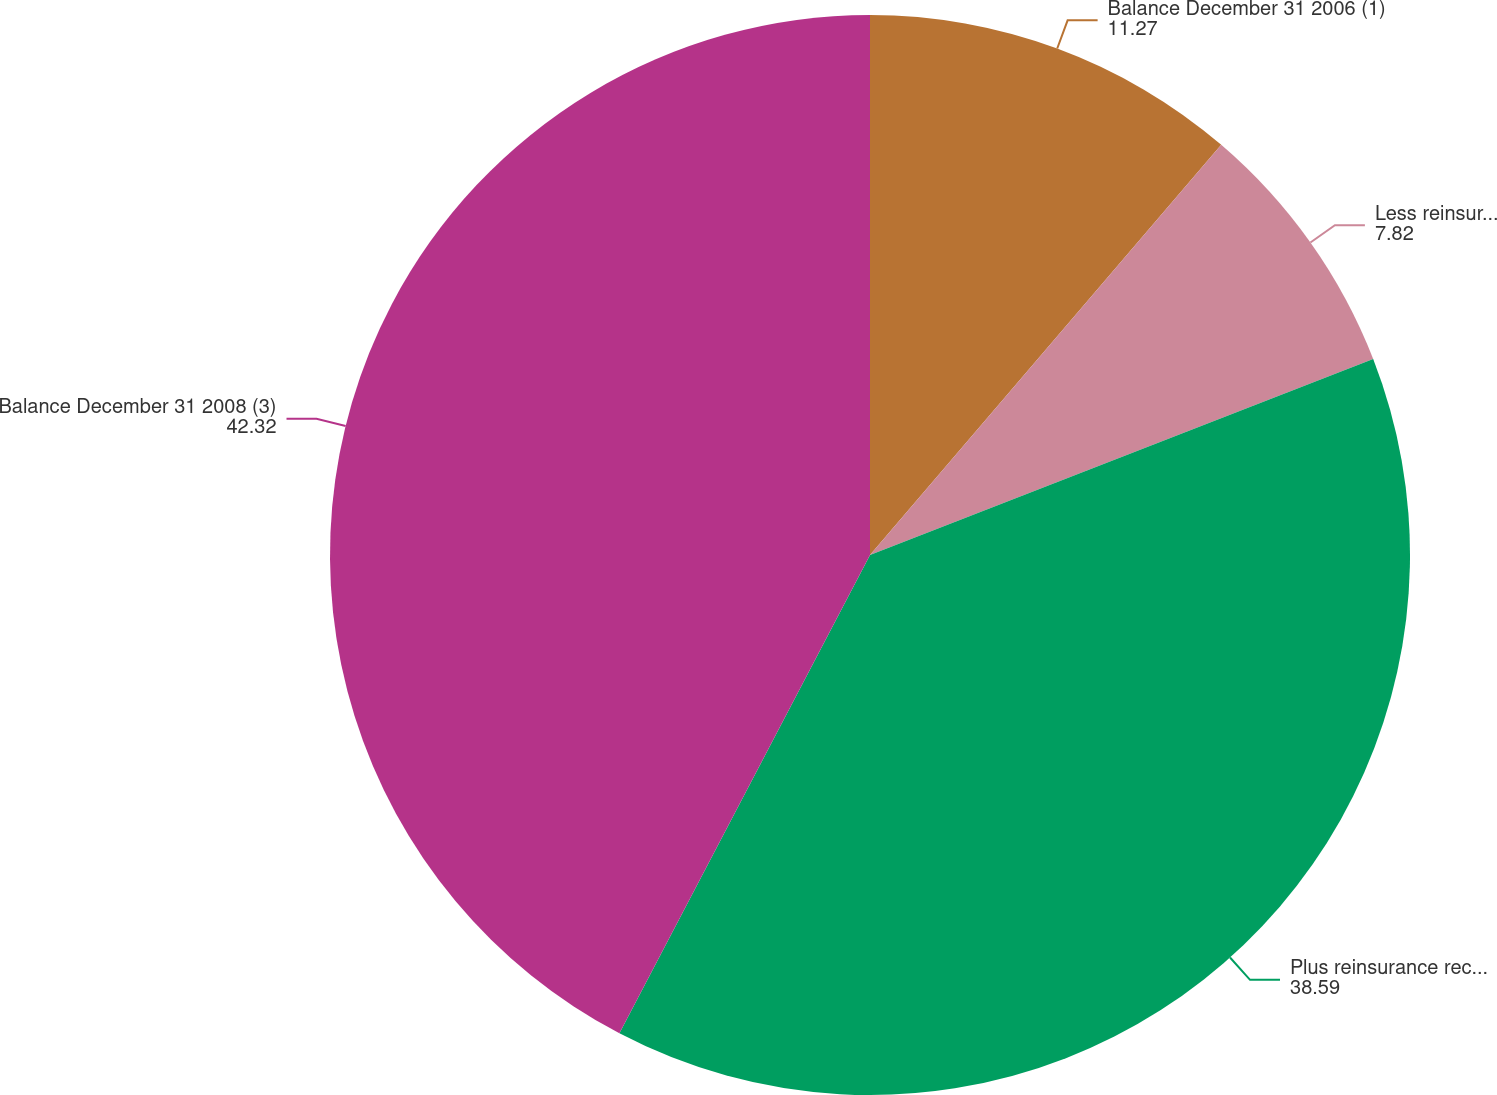<chart> <loc_0><loc_0><loc_500><loc_500><pie_chart><fcel>Balance December 31 2006 (1)<fcel>Less reinsurance recoverables<fcel>Plus reinsurance recoverables<fcel>Balance December 31 2008 (3)<nl><fcel>11.27%<fcel>7.82%<fcel>38.59%<fcel>42.32%<nl></chart> 